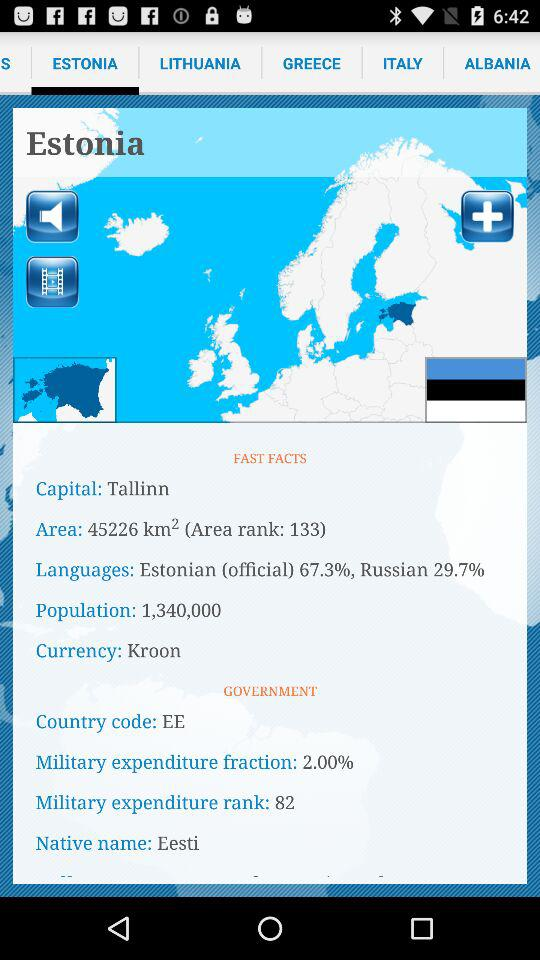What's the native name? The native name is Eesti. 